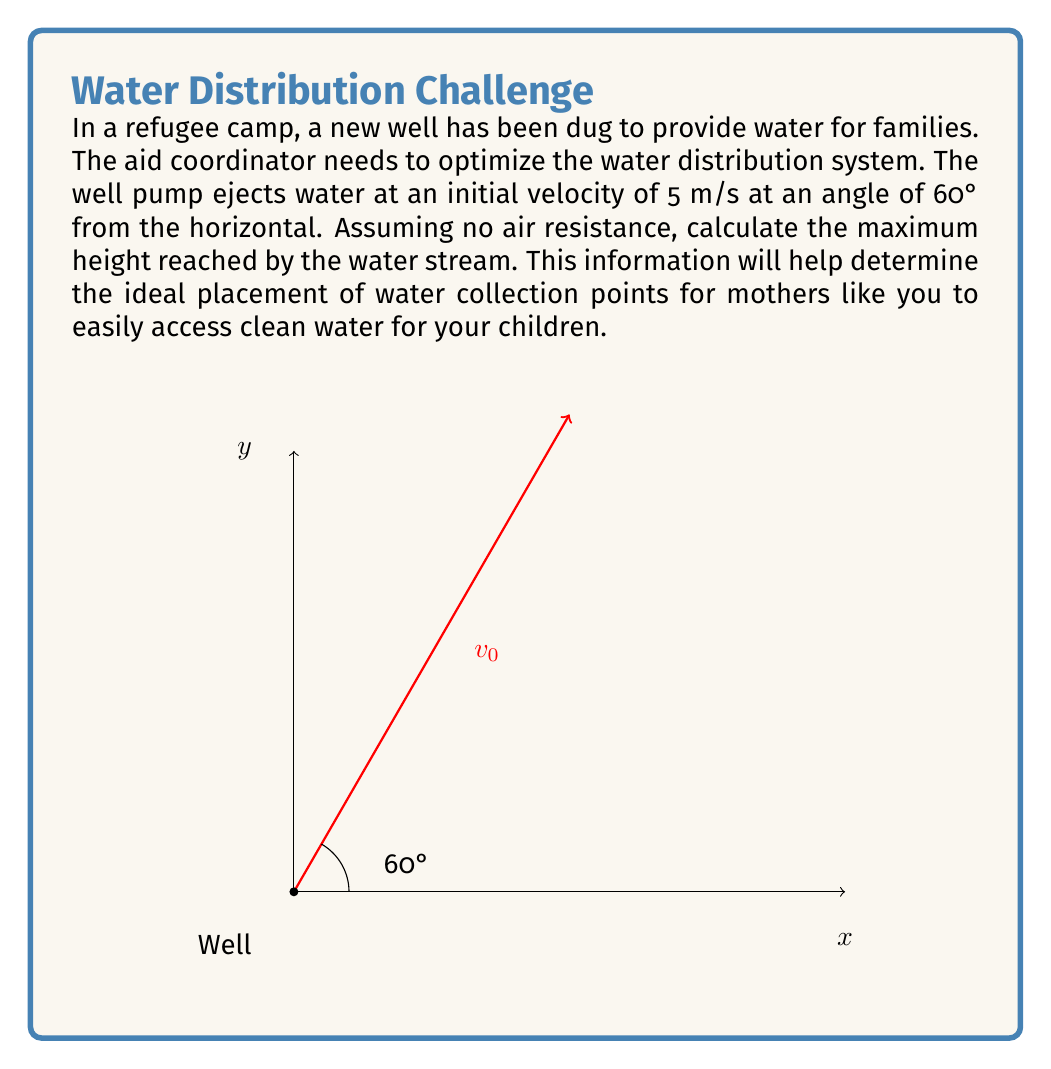What is the answer to this math problem? Let's approach this step-by-step:

1) The maximum height is reached when the vertical component of velocity becomes zero. We'll use the equation:

   $$v_y^2 = v_{0y}^2 - 2gy$$

   where $v_y$ is the final vertical velocity (0 at the highest point), $v_{0y}$ is the initial vertical velocity, $g$ is the acceleration due to gravity (9.8 m/s²), and $y$ is the maximum height.

2) First, we need to find the initial vertical velocity ($v_{0y}$):
   
   $$v_{0y} = v_0 \sin \theta = 5 \sin 60° = 5 \cdot \frac{\sqrt{3}}{2} = 4.33 \text{ m/s}$$

3) Now we can substitute into our equation:

   $$0^2 = (4.33)^2 - 2(9.8)y$$

4) Simplify:

   $$18.75 = 19.6y$$

5) Solve for $y$:

   $$y = \frac{18.75}{19.6} = 0.96 \text{ m}$$

Therefore, the maximum height reached by the water stream is approximately 0.96 meters.
Answer: 0.96 m 